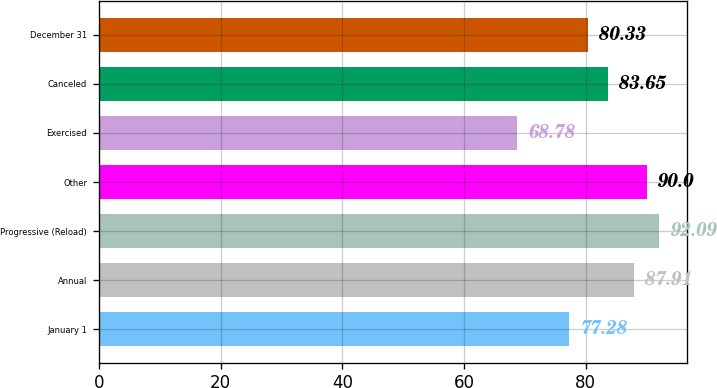Convert chart. <chart><loc_0><loc_0><loc_500><loc_500><bar_chart><fcel>January 1<fcel>Annual<fcel>Progressive (Reload)<fcel>Other<fcel>Exercised<fcel>Canceled<fcel>December 31<nl><fcel>77.28<fcel>87.91<fcel>92.09<fcel>90<fcel>68.78<fcel>83.65<fcel>80.33<nl></chart> 